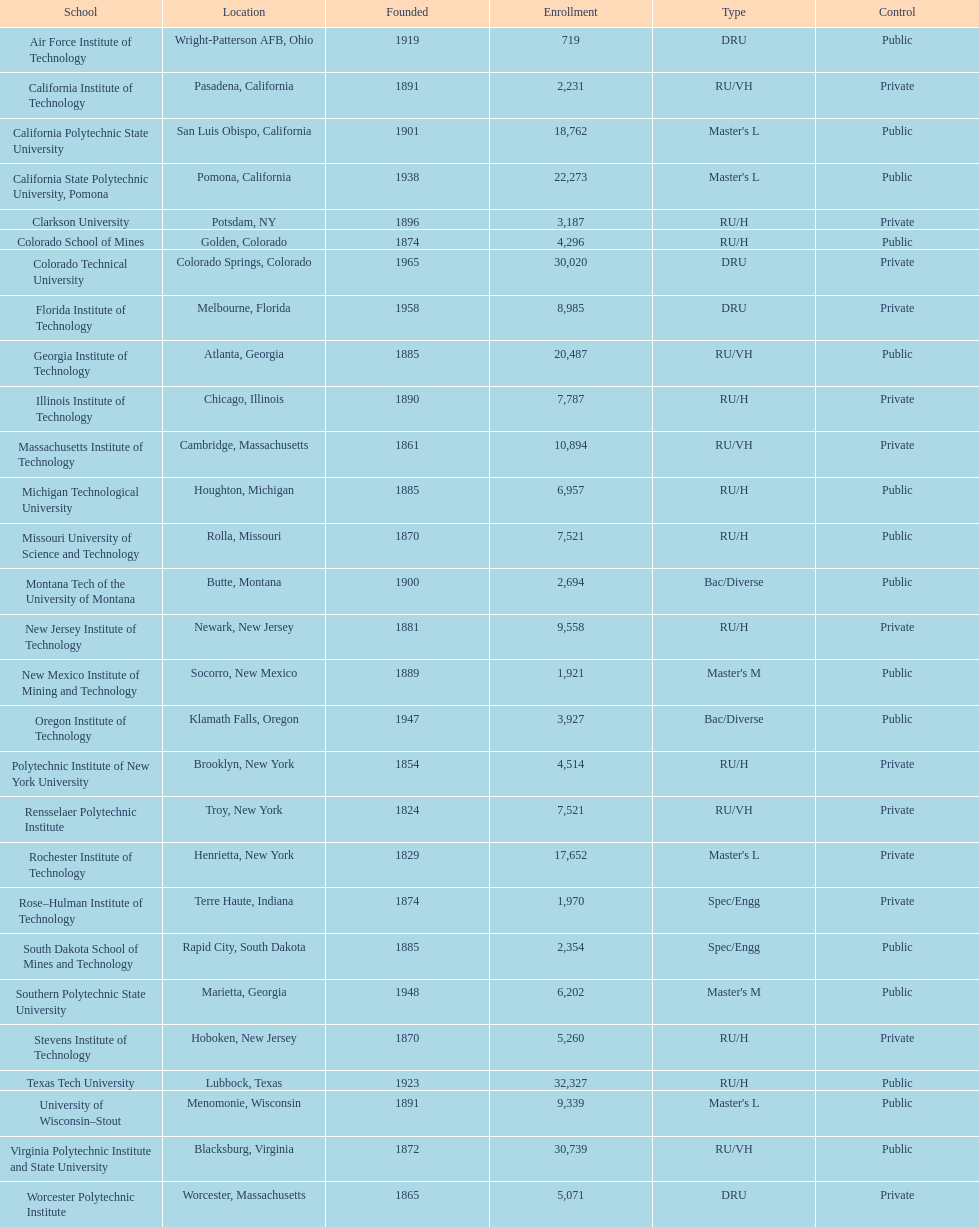What's the number of schools represented in the table? 28. 